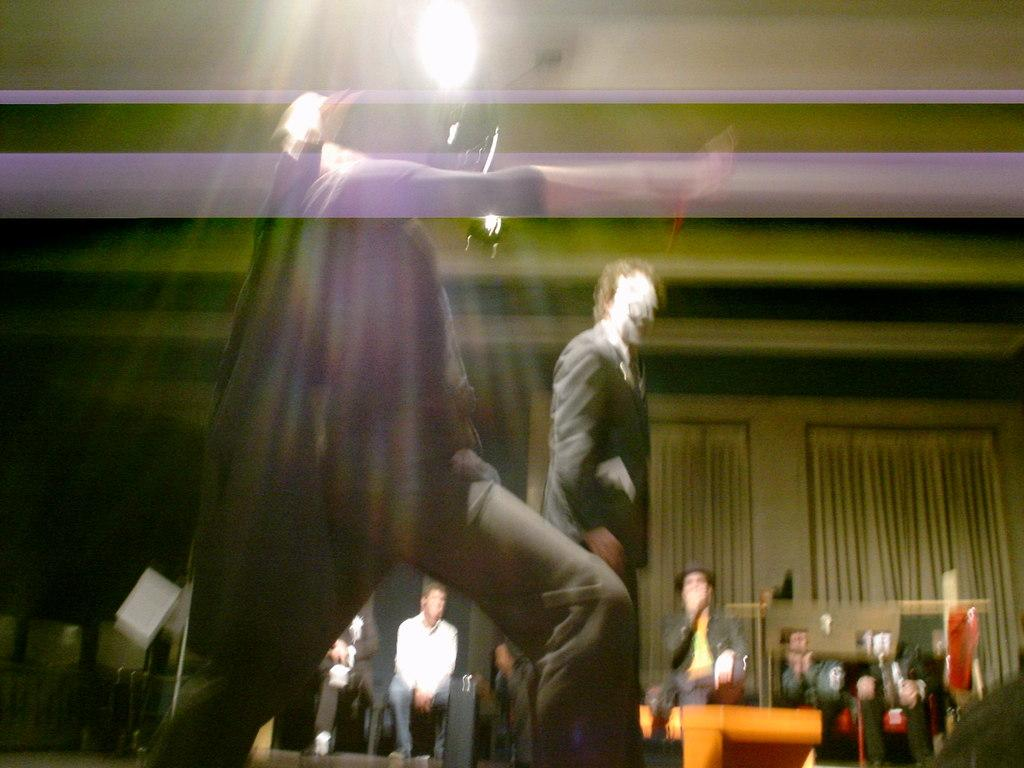What is the overall quality of the image? The image appears to be blurry. What are the people in the image doing? There are people walking and sitting in the image. Where is the light coming from in the image? The light is visible on the roof. How many pizzas are listed on the profit chart in the image? There is no pizza or profit chart present in the image. 